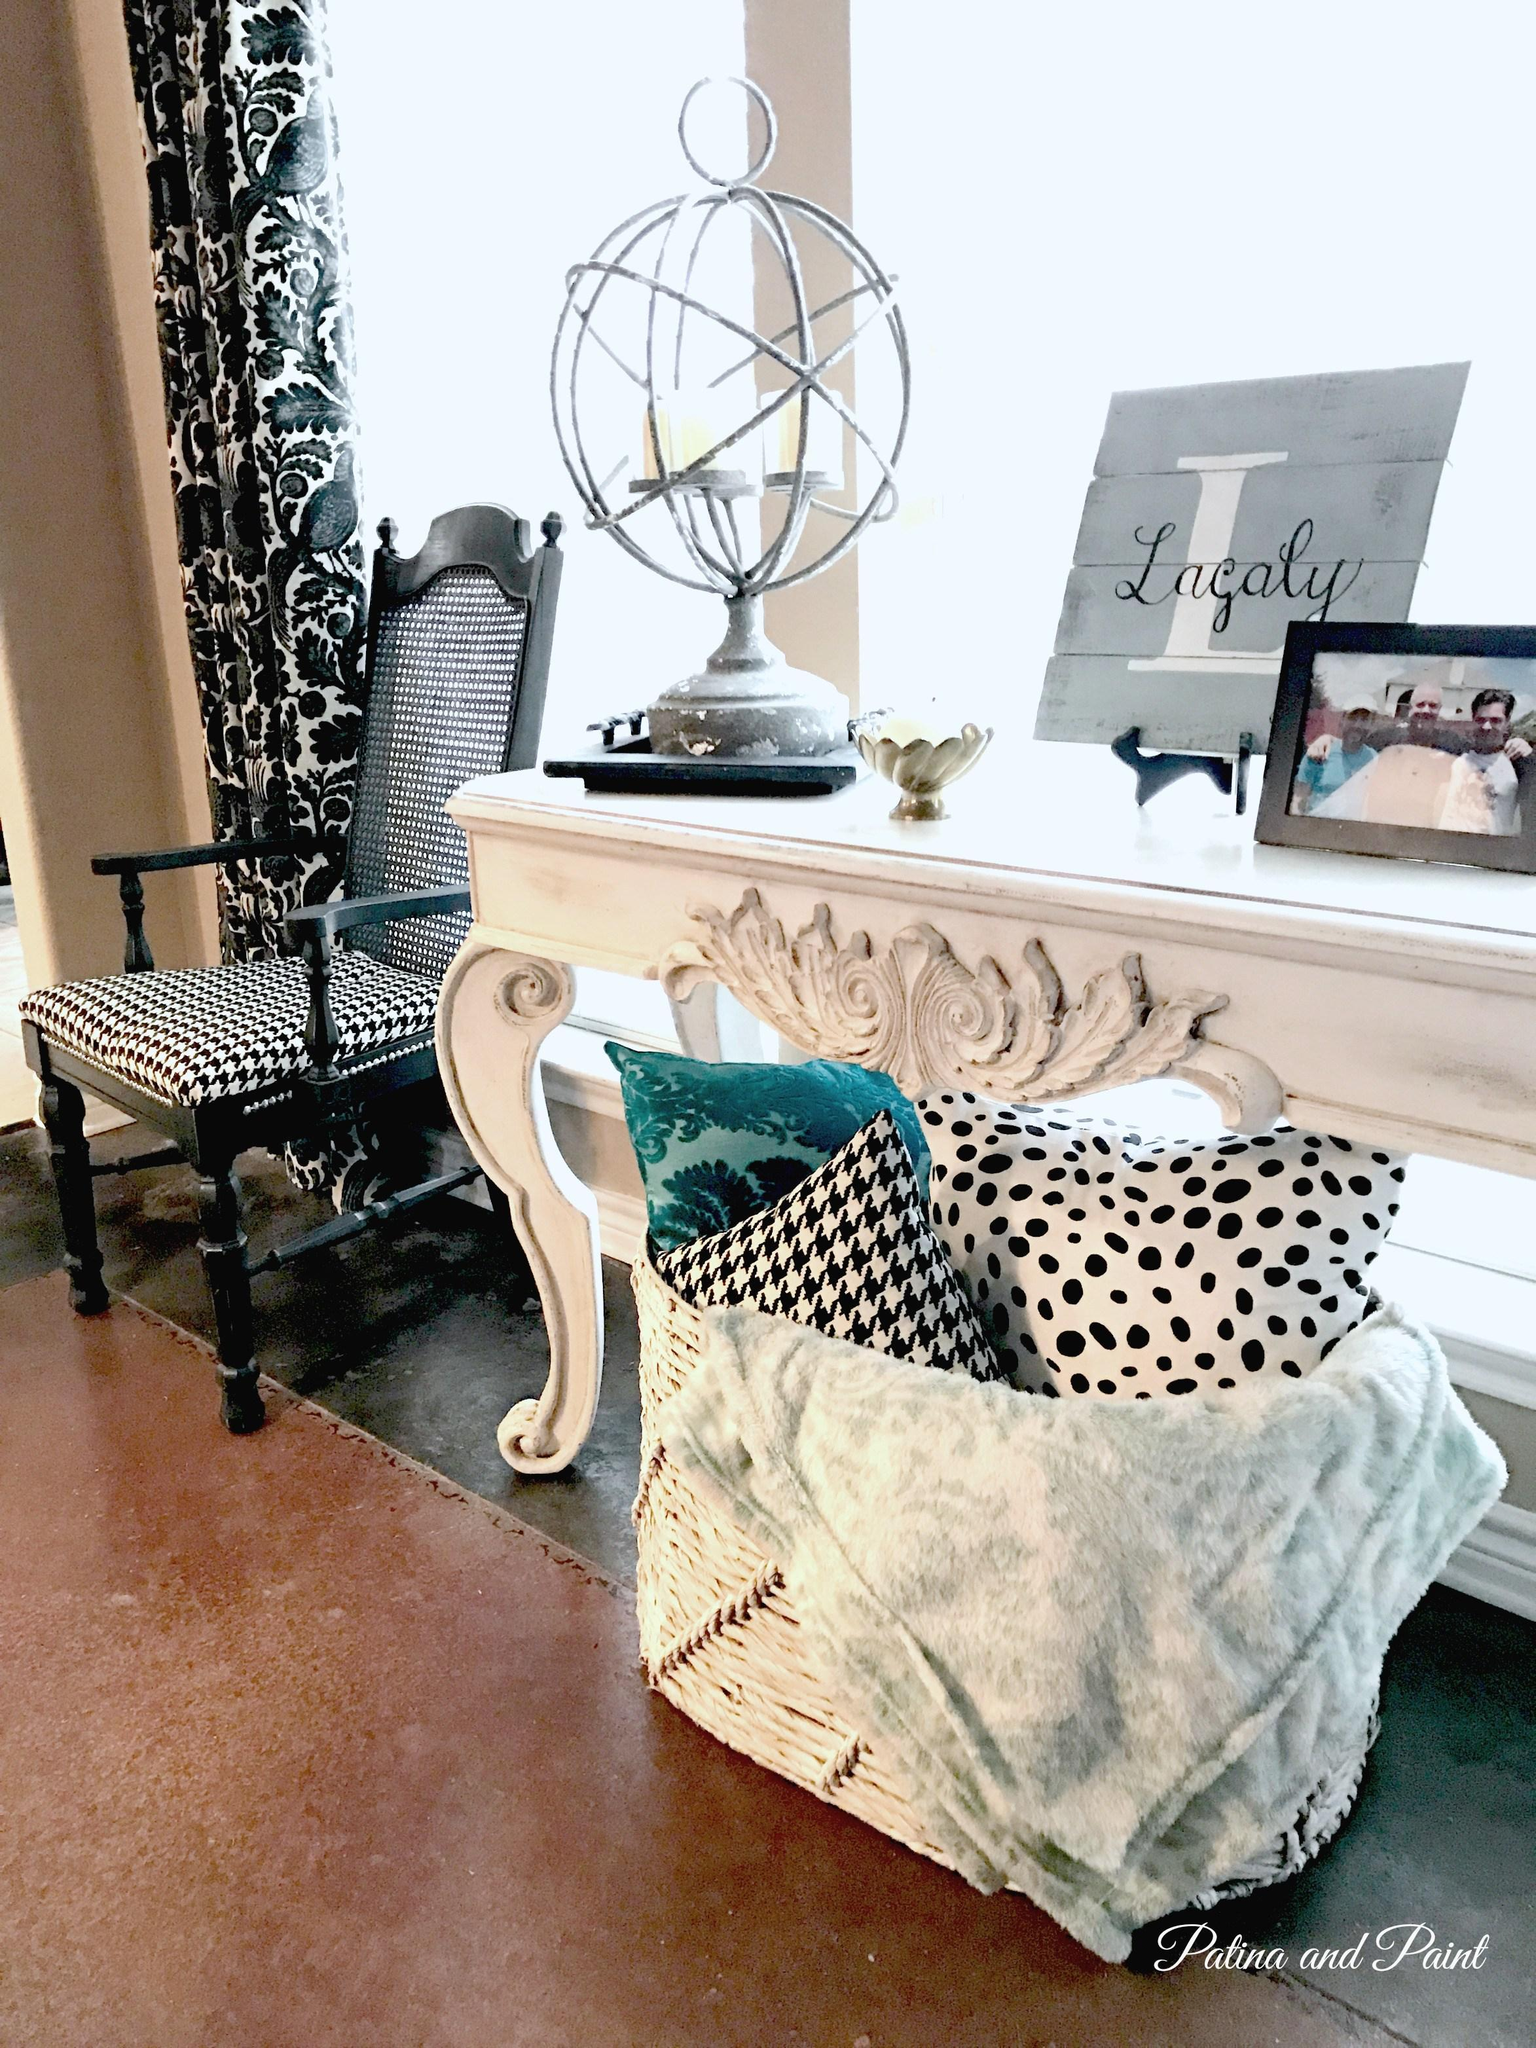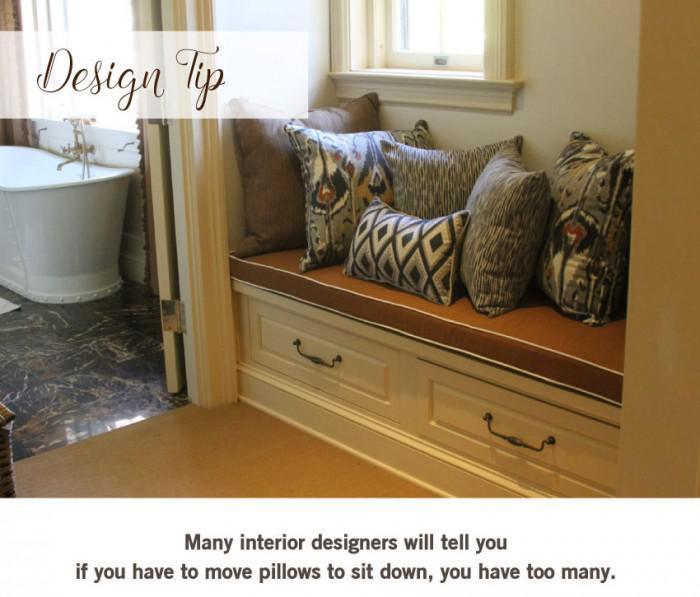The first image is the image on the left, the second image is the image on the right. Given the left and right images, does the statement "There are more than 5 frames on the wall in the image on the left." hold true? Answer yes or no. No. 